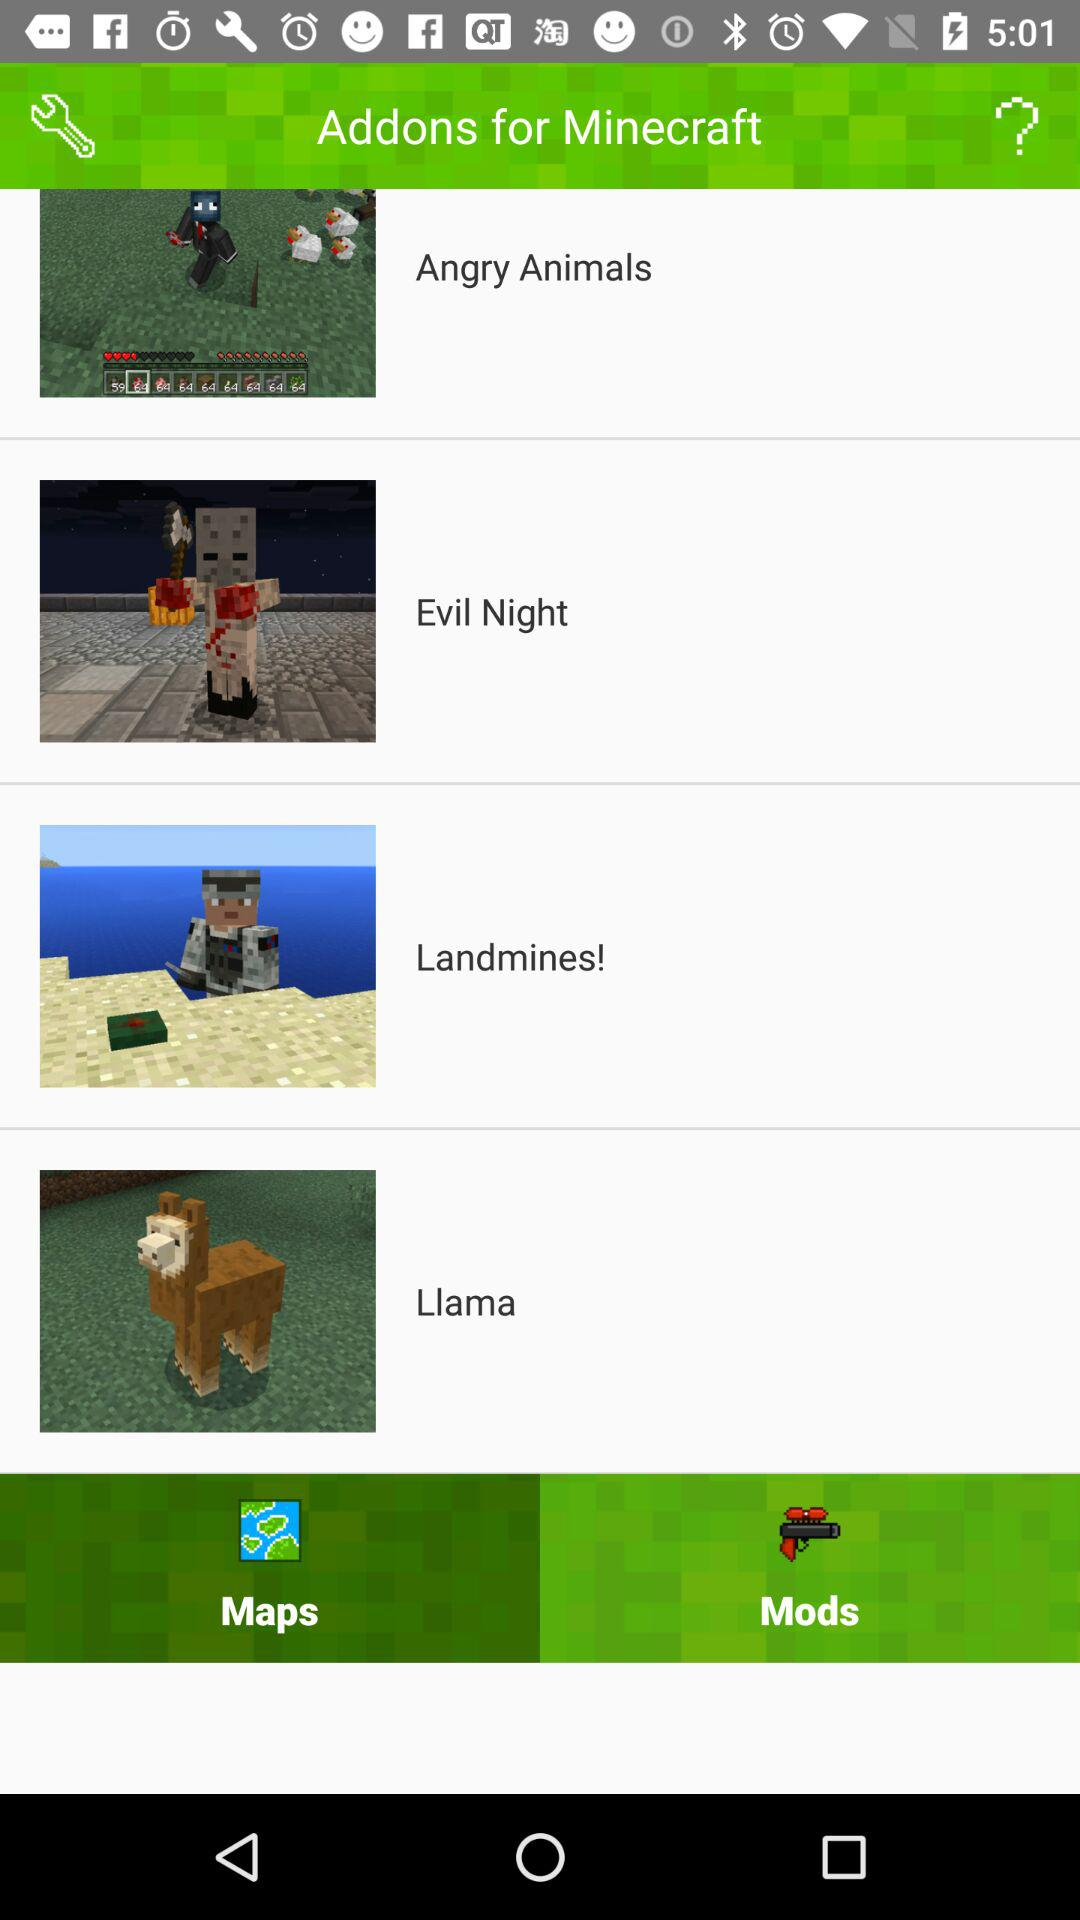What is the name of the application? The name of the application is "Addons for Minecraft". 